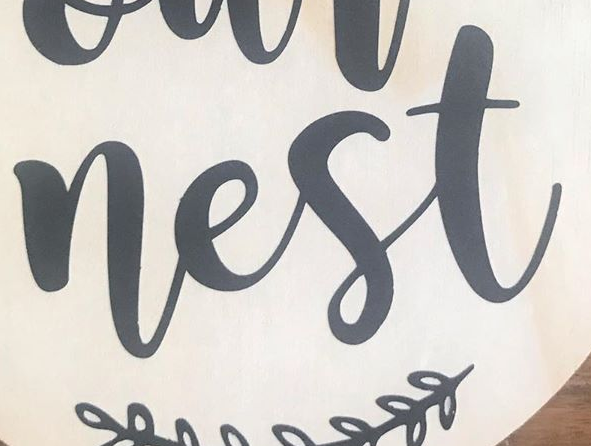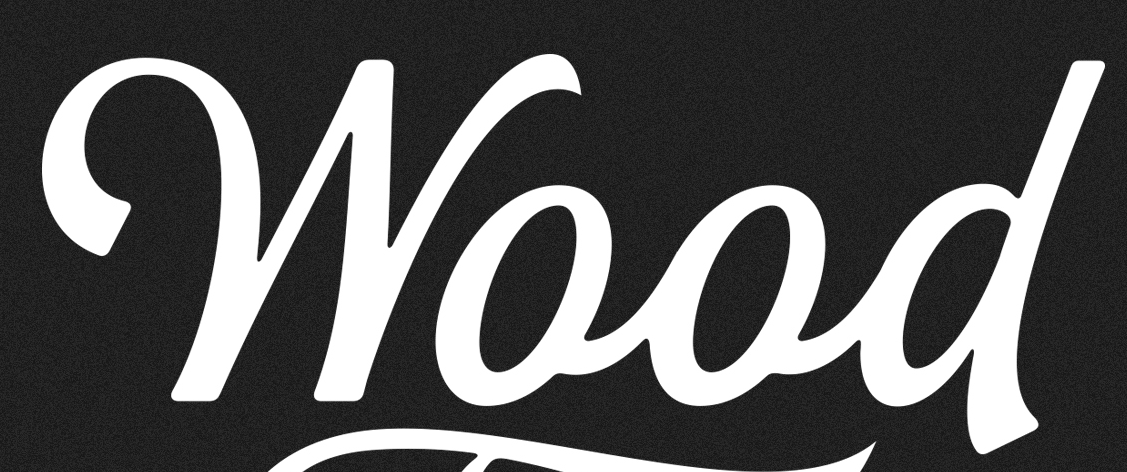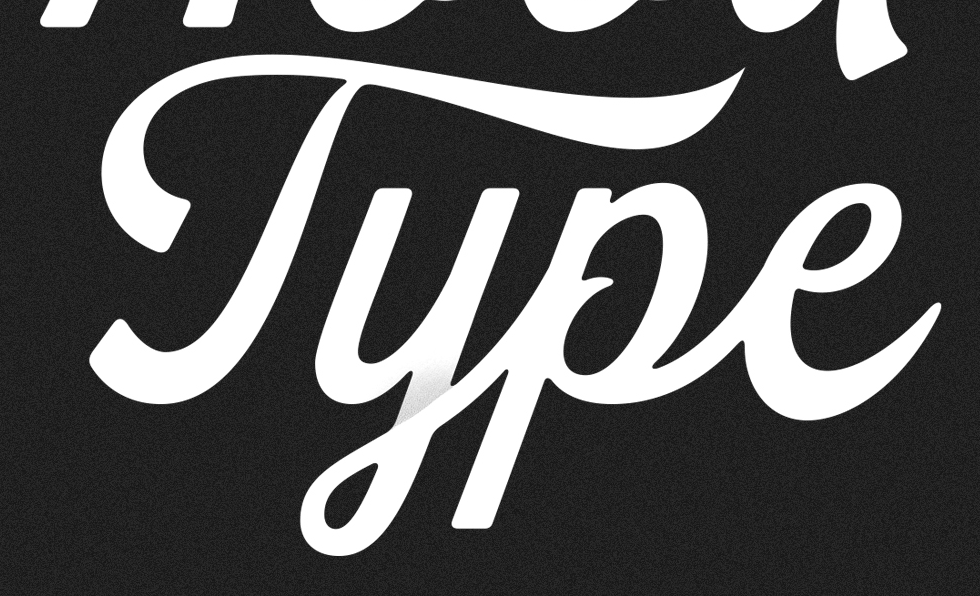What text is displayed in these images sequentially, separated by a semicolon? nest; Wood; Type 